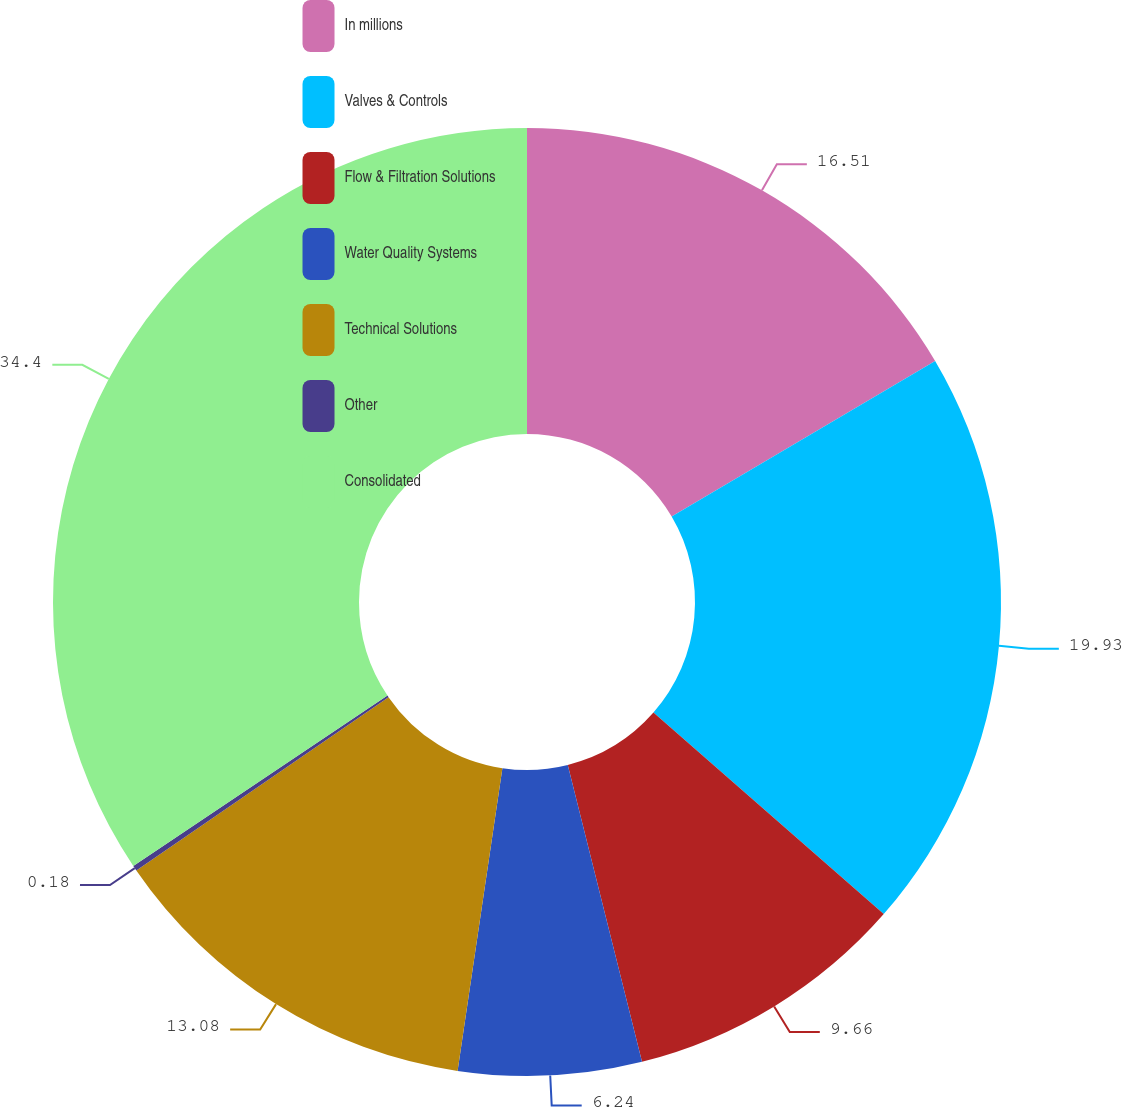<chart> <loc_0><loc_0><loc_500><loc_500><pie_chart><fcel>In millions<fcel>Valves & Controls<fcel>Flow & Filtration Solutions<fcel>Water Quality Systems<fcel>Technical Solutions<fcel>Other<fcel>Consolidated<nl><fcel>16.51%<fcel>19.93%<fcel>9.66%<fcel>6.24%<fcel>13.08%<fcel>0.18%<fcel>34.4%<nl></chart> 